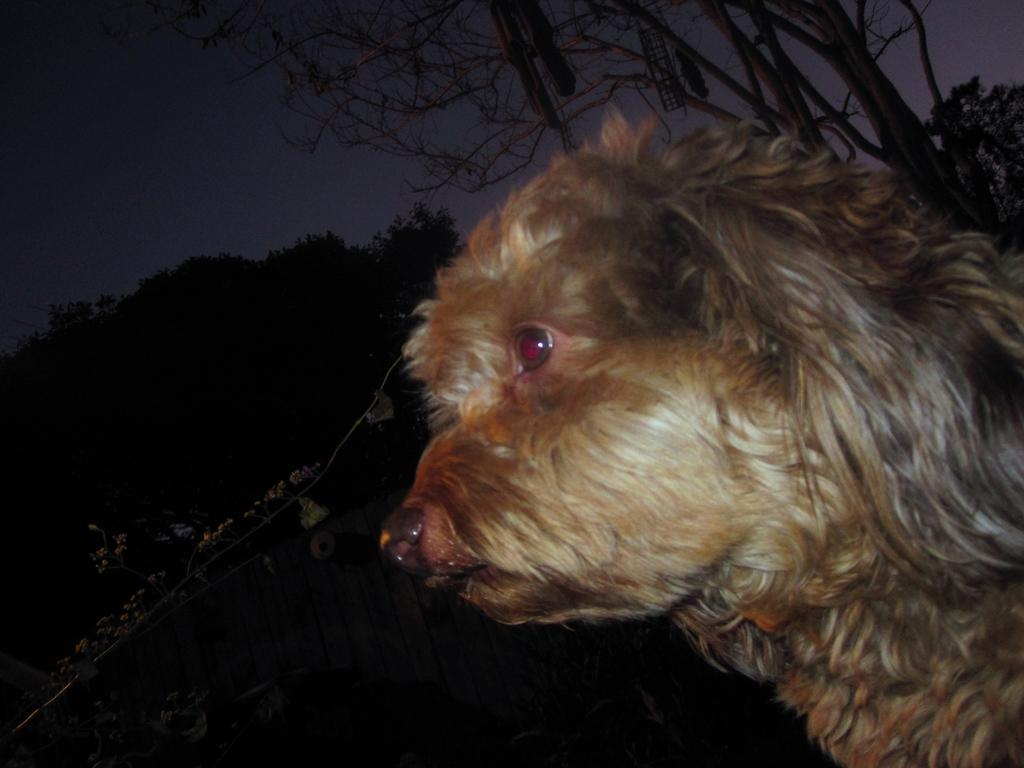What type of living creature is present in the image? There is an animal in the image. What type of natural environment is depicted in the image? There are trees in the image. What else can be seen in the image besides the animal and trees? There are objects in the image. What is visible in the background of the image? The sky is visible in the background of the image. How many tickets are visible in the image? There are no tickets present in the image. What type of club can be seen in the image? There is no club present in the image. 